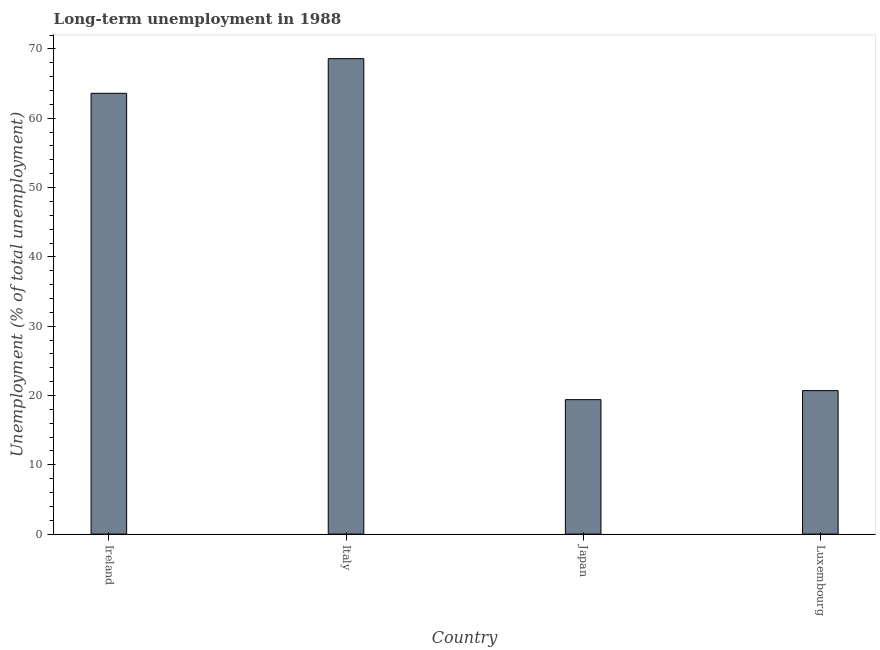Does the graph contain grids?
Keep it short and to the point. No. What is the title of the graph?
Keep it short and to the point. Long-term unemployment in 1988. What is the label or title of the X-axis?
Your response must be concise. Country. What is the label or title of the Y-axis?
Your answer should be very brief. Unemployment (% of total unemployment). What is the long-term unemployment in Luxembourg?
Ensure brevity in your answer.  20.7. Across all countries, what is the maximum long-term unemployment?
Offer a very short reply. 68.6. Across all countries, what is the minimum long-term unemployment?
Provide a short and direct response. 19.4. In which country was the long-term unemployment maximum?
Offer a terse response. Italy. In which country was the long-term unemployment minimum?
Provide a succinct answer. Japan. What is the sum of the long-term unemployment?
Provide a succinct answer. 172.3. What is the difference between the long-term unemployment in Italy and Luxembourg?
Keep it short and to the point. 47.9. What is the average long-term unemployment per country?
Offer a very short reply. 43.08. What is the median long-term unemployment?
Offer a very short reply. 42.15. In how many countries, is the long-term unemployment greater than 22 %?
Your answer should be very brief. 2. What is the ratio of the long-term unemployment in Italy to that in Japan?
Your answer should be compact. 3.54. What is the difference between the highest and the second highest long-term unemployment?
Offer a terse response. 5. What is the difference between the highest and the lowest long-term unemployment?
Offer a very short reply. 49.2. How many bars are there?
Keep it short and to the point. 4. Are all the bars in the graph horizontal?
Provide a succinct answer. No. What is the difference between two consecutive major ticks on the Y-axis?
Make the answer very short. 10. Are the values on the major ticks of Y-axis written in scientific E-notation?
Make the answer very short. No. What is the Unemployment (% of total unemployment) of Ireland?
Give a very brief answer. 63.6. What is the Unemployment (% of total unemployment) of Italy?
Provide a short and direct response. 68.6. What is the Unemployment (% of total unemployment) in Japan?
Give a very brief answer. 19.4. What is the Unemployment (% of total unemployment) of Luxembourg?
Your answer should be compact. 20.7. What is the difference between the Unemployment (% of total unemployment) in Ireland and Japan?
Make the answer very short. 44.2. What is the difference between the Unemployment (% of total unemployment) in Ireland and Luxembourg?
Your answer should be very brief. 42.9. What is the difference between the Unemployment (% of total unemployment) in Italy and Japan?
Make the answer very short. 49.2. What is the difference between the Unemployment (% of total unemployment) in Italy and Luxembourg?
Provide a short and direct response. 47.9. What is the difference between the Unemployment (% of total unemployment) in Japan and Luxembourg?
Your response must be concise. -1.3. What is the ratio of the Unemployment (% of total unemployment) in Ireland to that in Italy?
Make the answer very short. 0.93. What is the ratio of the Unemployment (% of total unemployment) in Ireland to that in Japan?
Provide a succinct answer. 3.28. What is the ratio of the Unemployment (% of total unemployment) in Ireland to that in Luxembourg?
Make the answer very short. 3.07. What is the ratio of the Unemployment (% of total unemployment) in Italy to that in Japan?
Your response must be concise. 3.54. What is the ratio of the Unemployment (% of total unemployment) in Italy to that in Luxembourg?
Your response must be concise. 3.31. What is the ratio of the Unemployment (% of total unemployment) in Japan to that in Luxembourg?
Offer a terse response. 0.94. 